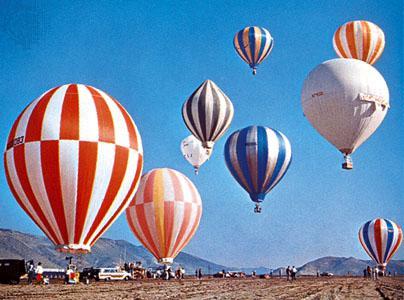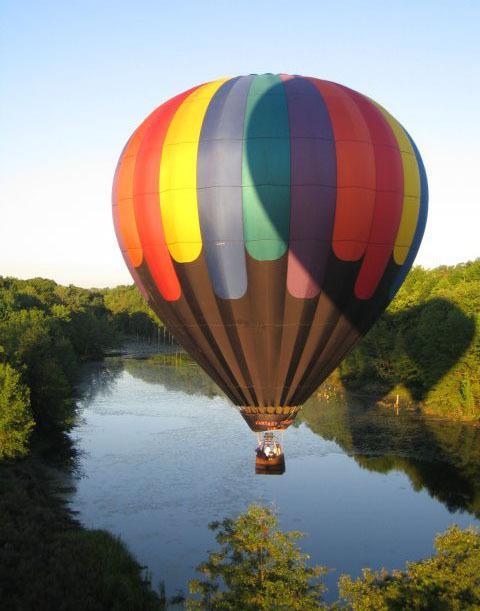The first image is the image on the left, the second image is the image on the right. Considering the images on both sides, is "One image contains at least 7 hot air balloons." valid? Answer yes or no. Yes. The first image is the image on the left, the second image is the image on the right. For the images displayed, is the sentence "Only one image in the pair contains a single balloon." factually correct? Answer yes or no. Yes. 